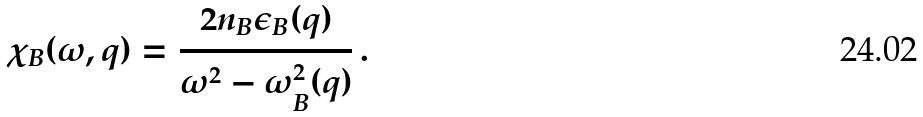<formula> <loc_0><loc_0><loc_500><loc_500>\chi _ { B } ( \omega , q ) = \frac { 2 n _ { B } \epsilon _ { B } ( q ) } { \omega ^ { 2 } - \omega _ { B } ^ { 2 } ( q ) } \, .</formula> 